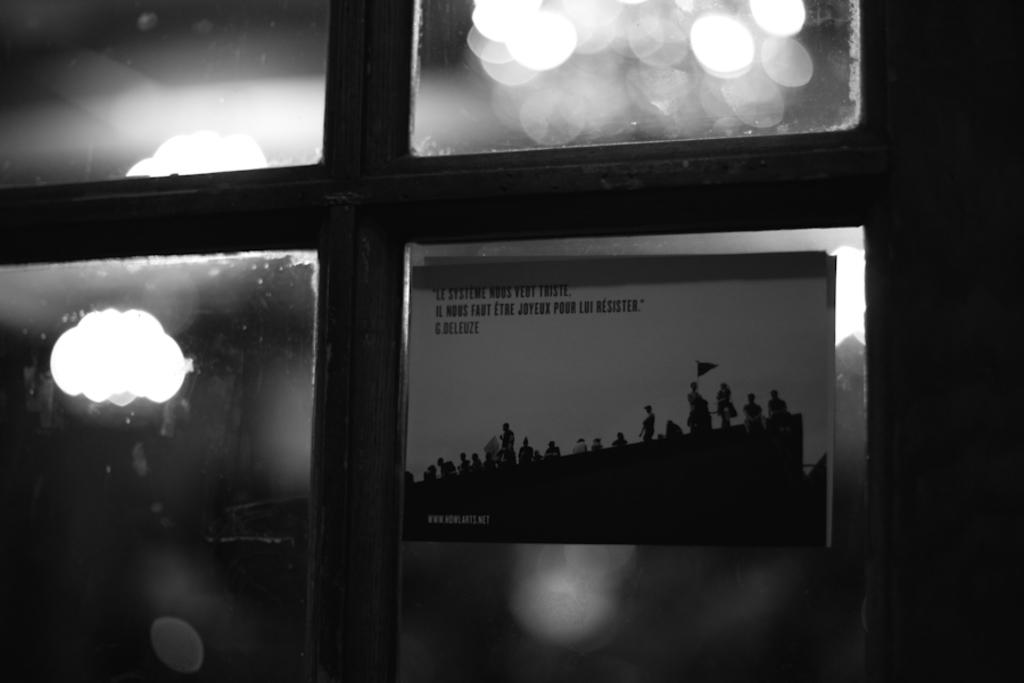What is the color scheme of the image? The image is black and white. What architectural feature can be seen in the image? There is a window in the image. What can be observed through the window? Lights and a poster are visible through the window. What type of cushion is placed on the car seat in the image? There is no car seat or cushion present in the image. How many spoons are visible in the image? There are no spoons visible in the image. 